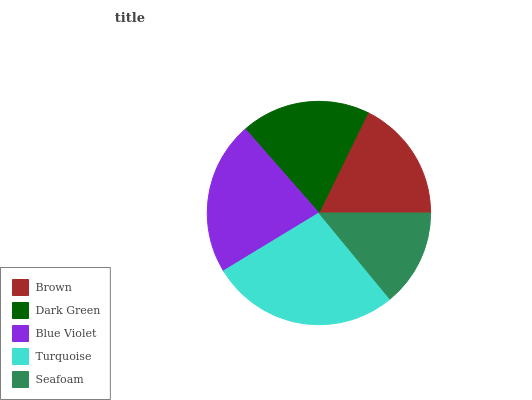Is Seafoam the minimum?
Answer yes or no. Yes. Is Turquoise the maximum?
Answer yes or no. Yes. Is Dark Green the minimum?
Answer yes or no. No. Is Dark Green the maximum?
Answer yes or no. No. Is Dark Green greater than Brown?
Answer yes or no. Yes. Is Brown less than Dark Green?
Answer yes or no. Yes. Is Brown greater than Dark Green?
Answer yes or no. No. Is Dark Green less than Brown?
Answer yes or no. No. Is Dark Green the high median?
Answer yes or no. Yes. Is Dark Green the low median?
Answer yes or no. Yes. Is Turquoise the high median?
Answer yes or no. No. Is Turquoise the low median?
Answer yes or no. No. 